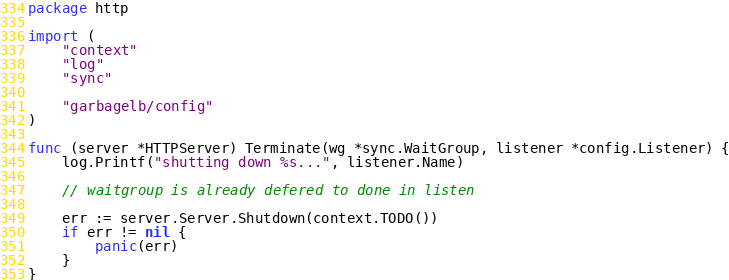<code> <loc_0><loc_0><loc_500><loc_500><_Go_>package http

import (
	"context"
	"log"
	"sync"

	"garbagelb/config"
)

func (server *HTTPServer) Terminate(wg *sync.WaitGroup, listener *config.Listener) {
	log.Printf("shutting down %s...", listener.Name)

	// waitgroup is already defered to done in listen

	err := server.Server.Shutdown(context.TODO())
	if err != nil {
		panic(err)
	}
}
</code> 